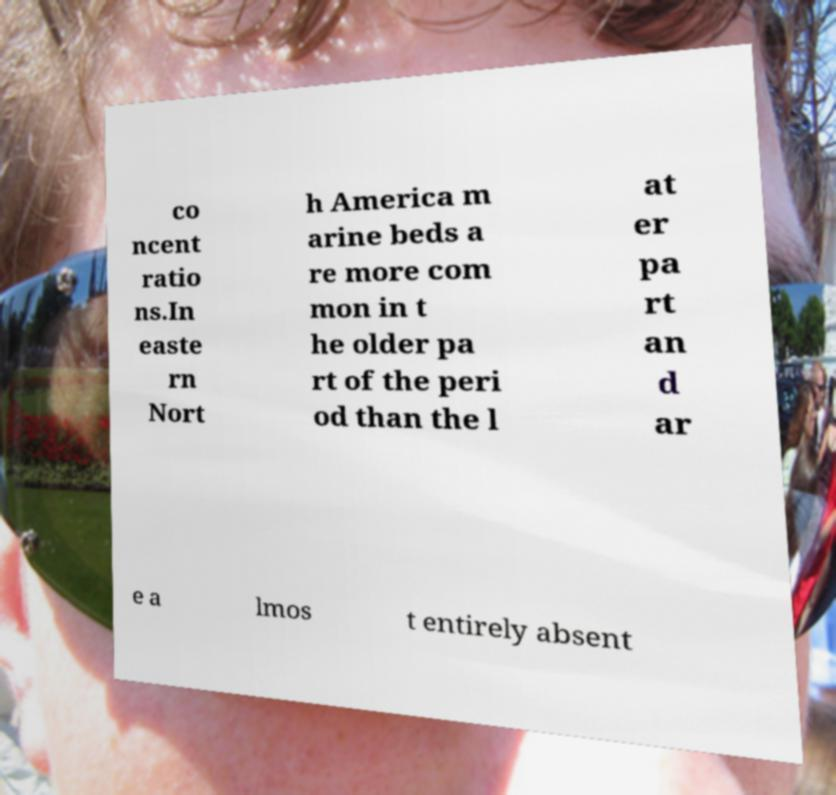There's text embedded in this image that I need extracted. Can you transcribe it verbatim? co ncent ratio ns.In easte rn Nort h America m arine beds a re more com mon in t he older pa rt of the peri od than the l at er pa rt an d ar e a lmos t entirely absent 